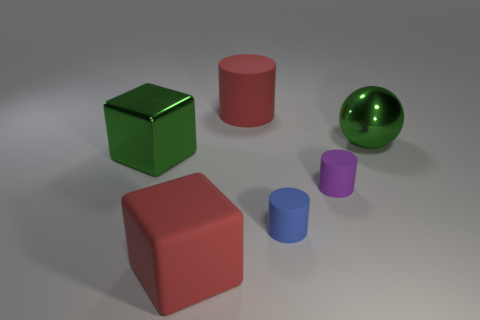There is a big red object that is in front of the large red cylinder; does it have the same shape as the tiny purple rubber object?
Keep it short and to the point. No. Is the purple thing the same shape as the blue object?
Make the answer very short. Yes. Is there a blue thing of the same shape as the small purple thing?
Your answer should be compact. Yes. There is a large shiny object on the left side of the shiny thing on the right side of the large red cylinder; what shape is it?
Offer a very short reply. Cube. What is the color of the cylinder that is in front of the purple matte thing?
Your answer should be compact. Blue. What is the size of the purple thing that is the same material as the small blue cylinder?
Make the answer very short. Small. There is a red matte object that is the same shape as the tiny blue rubber object; what is its size?
Give a very brief answer. Large. Are there any tiny blue metal cylinders?
Your answer should be very brief. No. How many objects are big things that are left of the large rubber cube or green blocks?
Offer a very short reply. 1. There is another cylinder that is the same size as the purple cylinder; what material is it?
Your answer should be very brief. Rubber. 